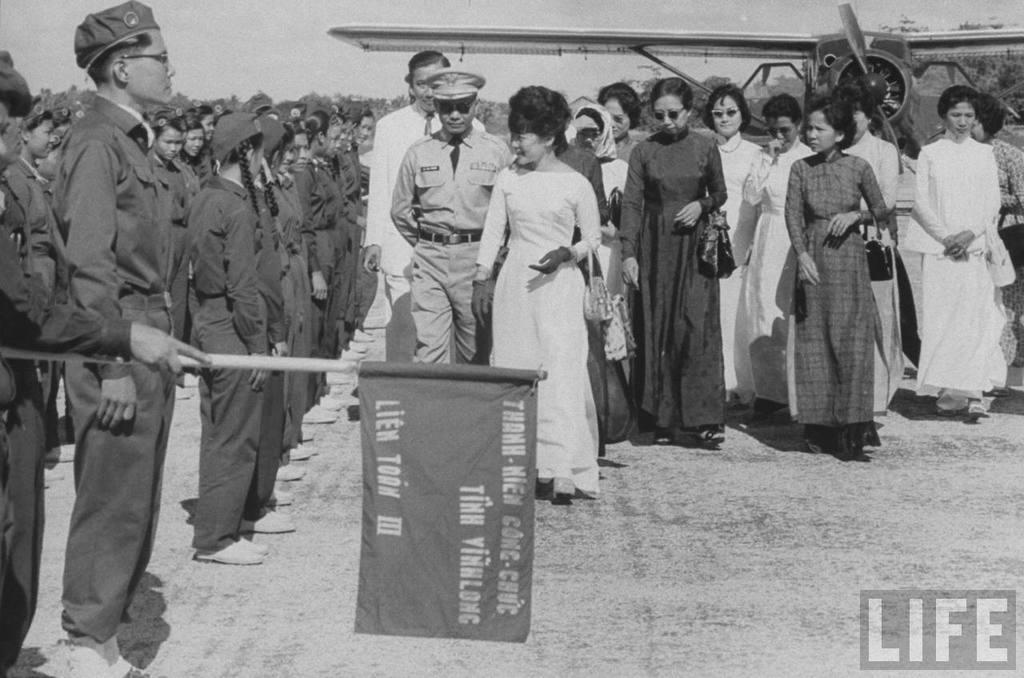<image>
Render a clear and concise summary of the photo. A woman in a dress walking by rows of people with the life logo on the bottom right. 